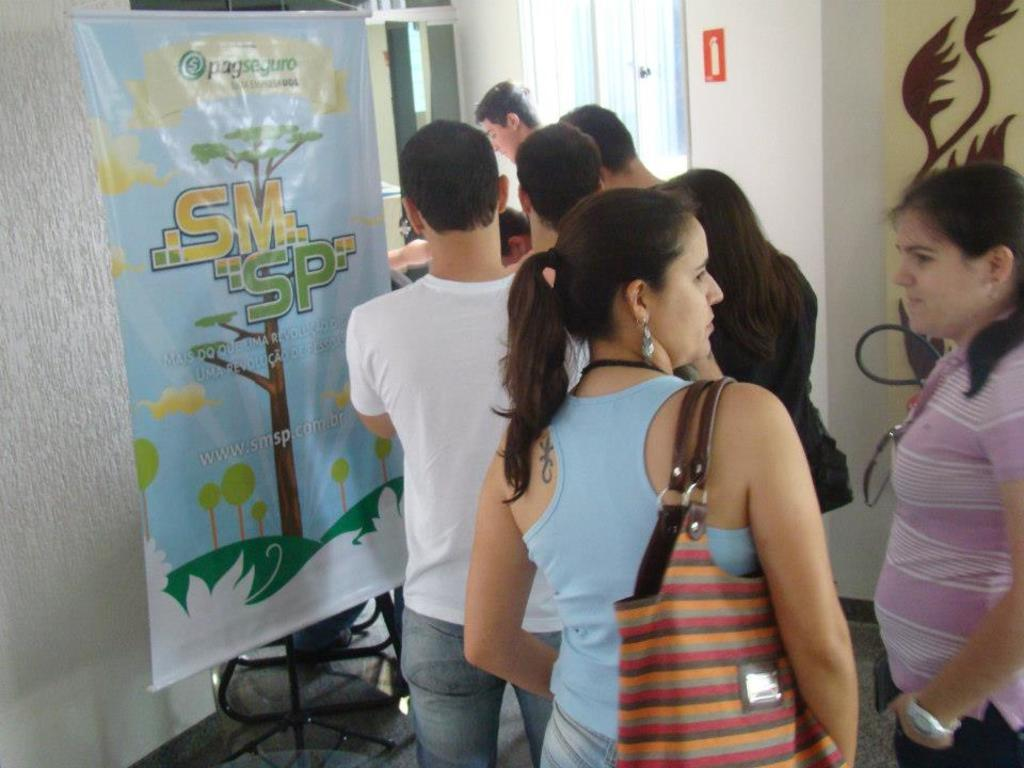Who is present in the image? There are men and women in the image. How are the people arranged in the image? They are standing in a line. Where is the line located in the image? The line is at the entrance of a room. What can be seen beside the door in the image? There is a banner beside the door. What type of record is being played in the image? There is no record player or music playing in the image. Can you see any kites flying in the image? There are no kites visible in the image. 